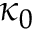<formula> <loc_0><loc_0><loc_500><loc_500>\kappa _ { 0 }</formula> 